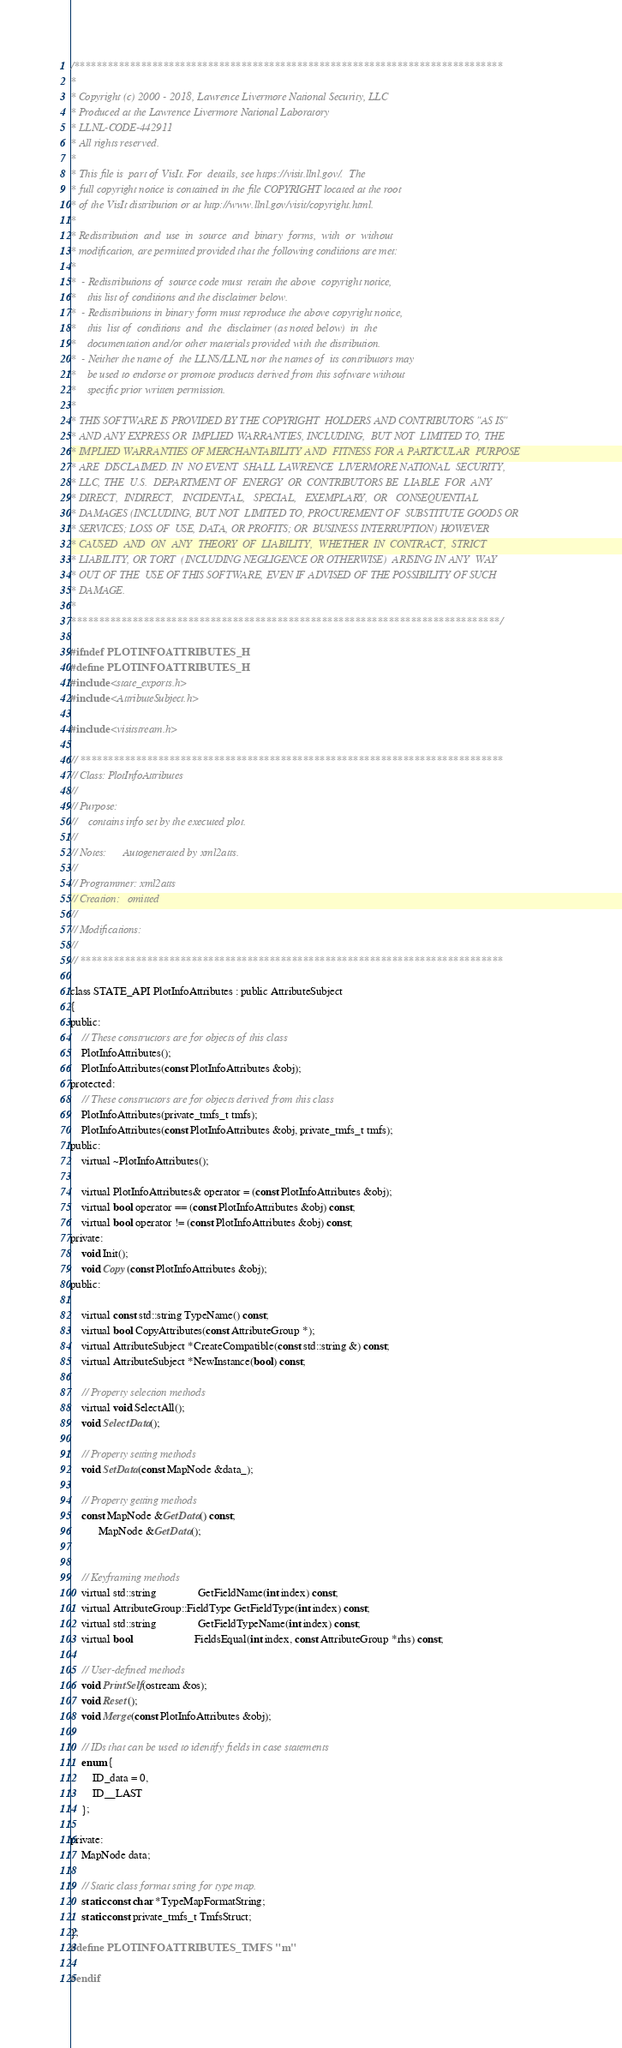<code> <loc_0><loc_0><loc_500><loc_500><_C_>/*****************************************************************************
*
* Copyright (c) 2000 - 2018, Lawrence Livermore National Security, LLC
* Produced at the Lawrence Livermore National Laboratory
* LLNL-CODE-442911
* All rights reserved.
*
* This file is  part of VisIt. For  details, see https://visit.llnl.gov/.  The
* full copyright notice is contained in the file COPYRIGHT located at the root
* of the VisIt distribution or at http://www.llnl.gov/visit/copyright.html.
*
* Redistribution  and  use  in  source  and  binary  forms,  with  or  without
* modification, are permitted provided that the following conditions are met:
*
*  - Redistributions of  source code must  retain the above  copyright notice,
*    this list of conditions and the disclaimer below.
*  - Redistributions in binary form must reproduce the above copyright notice,
*    this  list of  conditions  and  the  disclaimer (as noted below)  in  the
*    documentation and/or other materials provided with the distribution.
*  - Neither the name of  the LLNS/LLNL nor the names of  its contributors may
*    be used to endorse or promote products derived from this software without
*    specific prior written permission.
*
* THIS SOFTWARE IS PROVIDED BY THE COPYRIGHT  HOLDERS AND CONTRIBUTORS "AS IS"
* AND ANY EXPRESS OR  IMPLIED WARRANTIES, INCLUDING,  BUT NOT  LIMITED TO, THE
* IMPLIED WARRANTIES OF MERCHANTABILITY AND  FITNESS FOR A PARTICULAR  PURPOSE
* ARE  DISCLAIMED. IN  NO EVENT  SHALL LAWRENCE  LIVERMORE NATIONAL  SECURITY,
* LLC, THE  U.S.  DEPARTMENT OF  ENERGY  OR  CONTRIBUTORS BE  LIABLE  FOR  ANY
* DIRECT,  INDIRECT,   INCIDENTAL,   SPECIAL,   EXEMPLARY,  OR   CONSEQUENTIAL
* DAMAGES (INCLUDING, BUT NOT  LIMITED TO, PROCUREMENT OF  SUBSTITUTE GOODS OR
* SERVICES; LOSS OF  USE, DATA, OR PROFITS; OR  BUSINESS INTERRUPTION) HOWEVER
* CAUSED  AND  ON  ANY  THEORY  OF  LIABILITY,  WHETHER  IN  CONTRACT,  STRICT
* LIABILITY, OR TORT  (INCLUDING NEGLIGENCE OR OTHERWISE)  ARISING IN ANY  WAY
* OUT OF THE  USE OF THIS SOFTWARE, EVEN IF ADVISED OF THE POSSIBILITY OF SUCH
* DAMAGE.
*
*****************************************************************************/

#ifndef PLOTINFOATTRIBUTES_H
#define PLOTINFOATTRIBUTES_H
#include <state_exports.h>
#include <AttributeSubject.h>

#include <visitstream.h>

// ****************************************************************************
// Class: PlotInfoAttributes
//
// Purpose:
//    contains info set by the executed plot.
//
// Notes:      Autogenerated by xml2atts.
//
// Programmer: xml2atts
// Creation:   omitted
//
// Modifications:
//   
// ****************************************************************************

class STATE_API PlotInfoAttributes : public AttributeSubject
{
public:
    // These constructors are for objects of this class
    PlotInfoAttributes();
    PlotInfoAttributes(const PlotInfoAttributes &obj);
protected:
    // These constructors are for objects derived from this class
    PlotInfoAttributes(private_tmfs_t tmfs);
    PlotInfoAttributes(const PlotInfoAttributes &obj, private_tmfs_t tmfs);
public:
    virtual ~PlotInfoAttributes();

    virtual PlotInfoAttributes& operator = (const PlotInfoAttributes &obj);
    virtual bool operator == (const PlotInfoAttributes &obj) const;
    virtual bool operator != (const PlotInfoAttributes &obj) const;
private:
    void Init();
    void Copy(const PlotInfoAttributes &obj);
public:

    virtual const std::string TypeName() const;
    virtual bool CopyAttributes(const AttributeGroup *);
    virtual AttributeSubject *CreateCompatible(const std::string &) const;
    virtual AttributeSubject *NewInstance(bool) const;

    // Property selection methods
    virtual void SelectAll();
    void SelectData();

    // Property setting methods
    void SetData(const MapNode &data_);

    // Property getting methods
    const MapNode &GetData() const;
          MapNode &GetData();


    // Keyframing methods
    virtual std::string               GetFieldName(int index) const;
    virtual AttributeGroup::FieldType GetFieldType(int index) const;
    virtual std::string               GetFieldTypeName(int index) const;
    virtual bool                      FieldsEqual(int index, const AttributeGroup *rhs) const;

    // User-defined methods
    void PrintSelf(ostream &os);
    void Reset();
    void Merge(const PlotInfoAttributes &obj);

    // IDs that can be used to identify fields in case statements
    enum {
        ID_data = 0,
        ID__LAST
    };

private:
    MapNode data;

    // Static class format string for type map.
    static const char *TypeMapFormatString;
    static const private_tmfs_t TmfsStruct;
};
#define PLOTINFOATTRIBUTES_TMFS "m"

#endif
</code> 